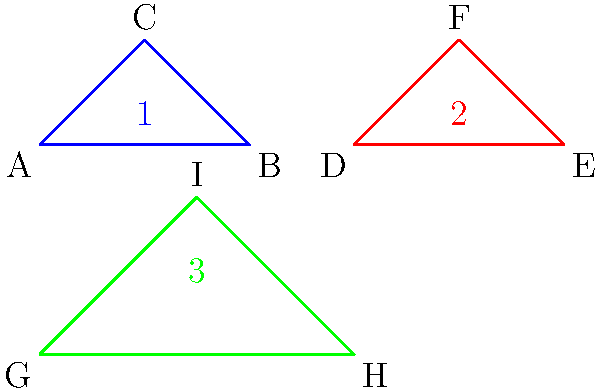In the diagram above, three dental instruments are represented by triangles. Which two instruments are congruent, ensuring that they can be used interchangeably in dental procedures? To determine which two instruments are congruent, we need to compare the triangles representing them. Congruent triangles have the same shape and size. Let's analyze each triangle:

1. Triangle 1 (ABC):
   Base length: 2 units
   Height: 1 unit

2. Triangle 2 (DEF):
   Base length: 2 units
   Height: 1 unit

3. Triangle 3 (GHI):
   Base length: 3 units
   Height: 1.5 units

Step 1: Compare the base lengths and heights of the triangles.
- Triangles 1 and 2 have the same base length (2 units) and height (1 unit).
- Triangle 3 has a different base length (3 units) and height (1.5 units).

Step 2: Check for scaling.
- Triangles 1 and 2 have the same dimensions, indicating they are not scaled versions of each other.
- Triangle 3 is larger than the other two and has different proportions.

Step 3: Conclude based on the comparisons.
- Triangles 1 and 2 have the same shape and size, making them congruent.
- Triangle 3 is not congruent to either Triangle 1 or Triangle 2.

Therefore, the dental instruments represented by Triangles 1 and 2 are congruent and can be used interchangeably in dental procedures.
Answer: Instruments 1 and 2 